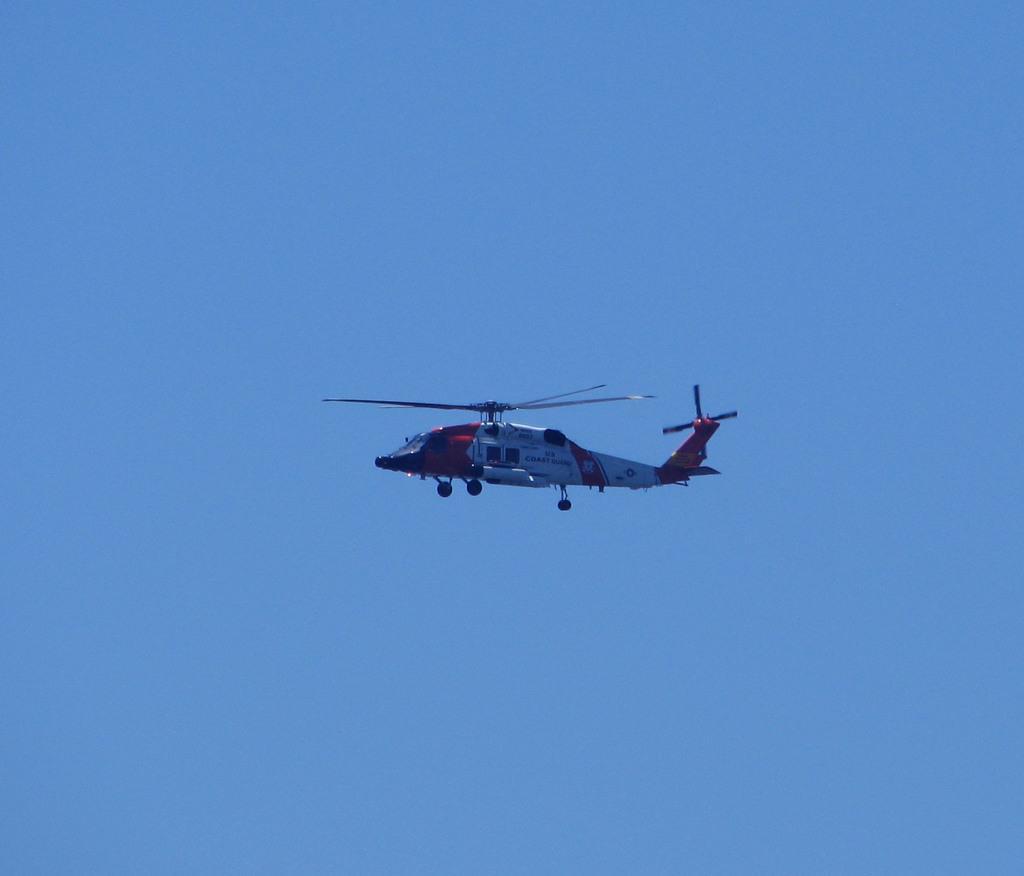Could you give a brief overview of what you see in this image? In this image we can see a helicopter flying in the sky. 